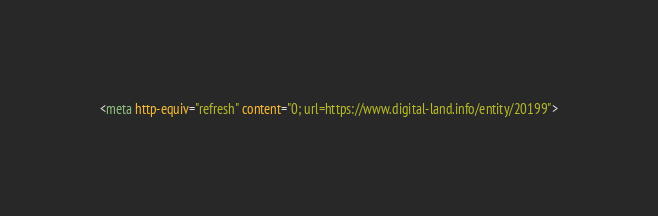<code> <loc_0><loc_0><loc_500><loc_500><_HTML_><meta http-equiv="refresh" content="0; url=https://www.digital-land.info/entity/20199"></code> 